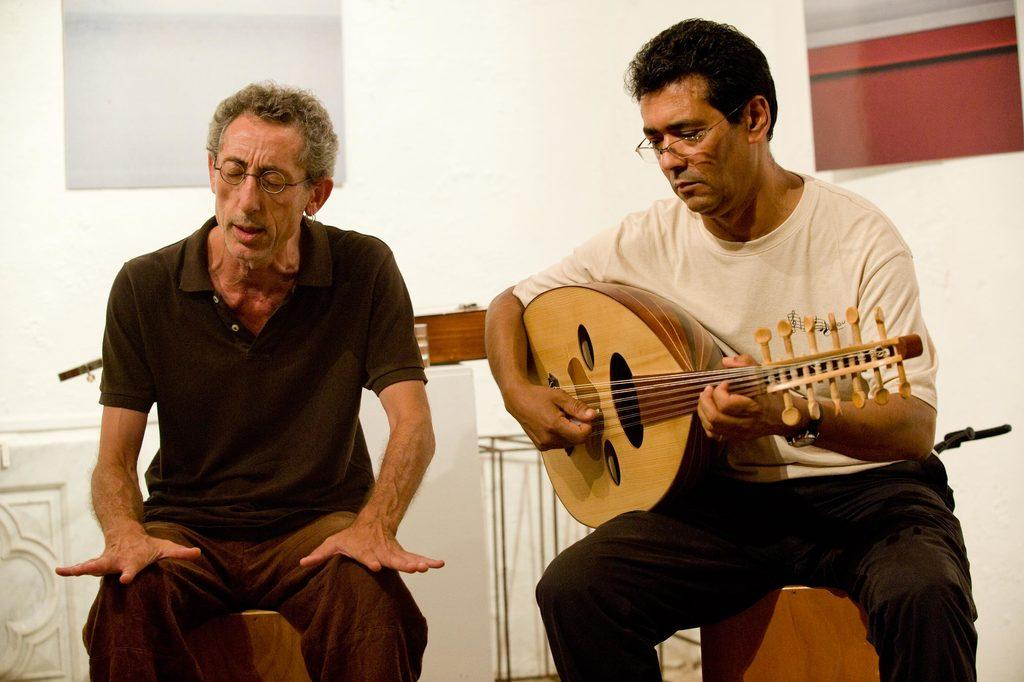How many people are in the image? There are two persons in the image. What are the persons doing in the image? The persons are sitting on chairs. Can you describe one of the persons in the image? One person is wearing spectacles and playing a guitar. What can be seen in the background of the image? There is a wall visible in the background of the image. What type of pollution can be seen in the image? There is no pollution visible in the image. How does the string connect the two persons in the image? There is no string connecting the two persons in the image. 